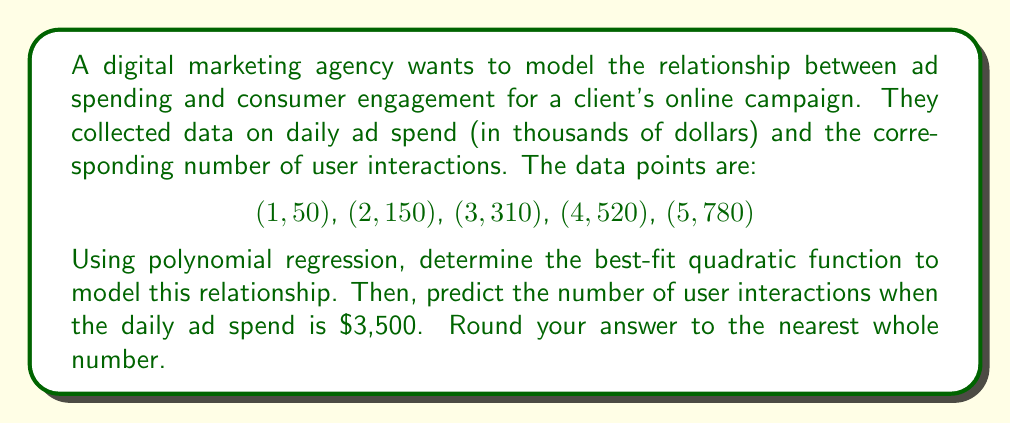Can you answer this question? 1) For a quadratic polynomial regression, we use the model:
   $y = ax^2 + bx + c$

2) We need to solve the normal equations:
   $$\begin{bmatrix}
   \sum x^4 & \sum x^3 & \sum x^2 \\
   \sum x^3 & \sum x^2 & \sum x \\
   \sum x^2 & \sum x & n
   \end{bmatrix}
   \begin{bmatrix}
   a \\ b \\ c
   \end{bmatrix} =
   \begin{bmatrix}
   \sum x^2y \\ \sum xy \\ \sum y
   \end{bmatrix}$$

3) Calculate the sums:
   $\sum x^4 = 1^4 + 2^4 + 3^4 + 4^4 + 5^4 = 979$
   $\sum x^3 = 1^3 + 2^3 + 3^3 + 4^3 + 5^3 = 225$
   $\sum x^2 = 1^2 + 2^2 + 3^2 + 4^2 + 5^2 = 55$
   $\sum x = 1 + 2 + 3 + 4 + 5 = 15$
   $n = 5$
   $\sum x^2y = 1^2(50) + 2^2(150) + 3^2(310) + 4^2(520) + 5^2(780) = 13,750$
   $\sum xy = 1(50) + 2(150) + 3(310) + 4(520) + 5(780) = 5,710$
   $\sum y = 50 + 150 + 310 + 520 + 780 = 1,810$

4) Substituting into the matrix equation:
   $$\begin{bmatrix}
   979 & 225 & 55 \\
   225 & 55 & 15 \\
   55 & 15 & 5
   \end{bmatrix}
   \begin{bmatrix}
   a \\ b \\ c
   \end{bmatrix} =
   \begin{bmatrix}
   13,750 \\ 5,710 \\ 1,810
   \end{bmatrix}$$

5) Solving this system of equations (using a calculator or computer algebra system):
   $a = 10$
   $b = 30$
   $c = 10$

6) Therefore, the quadratic function is:
   $y = 10x^2 + 30x + 10$

7) To predict the number of user interactions when the daily ad spend is $3,500:
   $x = 3.5$ (since the input is in thousands of dollars)
   
   $y = 10(3.5)^2 + 30(3.5) + 10$
   $= 10(12.25) + 105 + 10$
   $= 122.5 + 105 + 10$
   $= 237.5$

8) Rounding to the nearest whole number: 238
Answer: 238 user interactions 